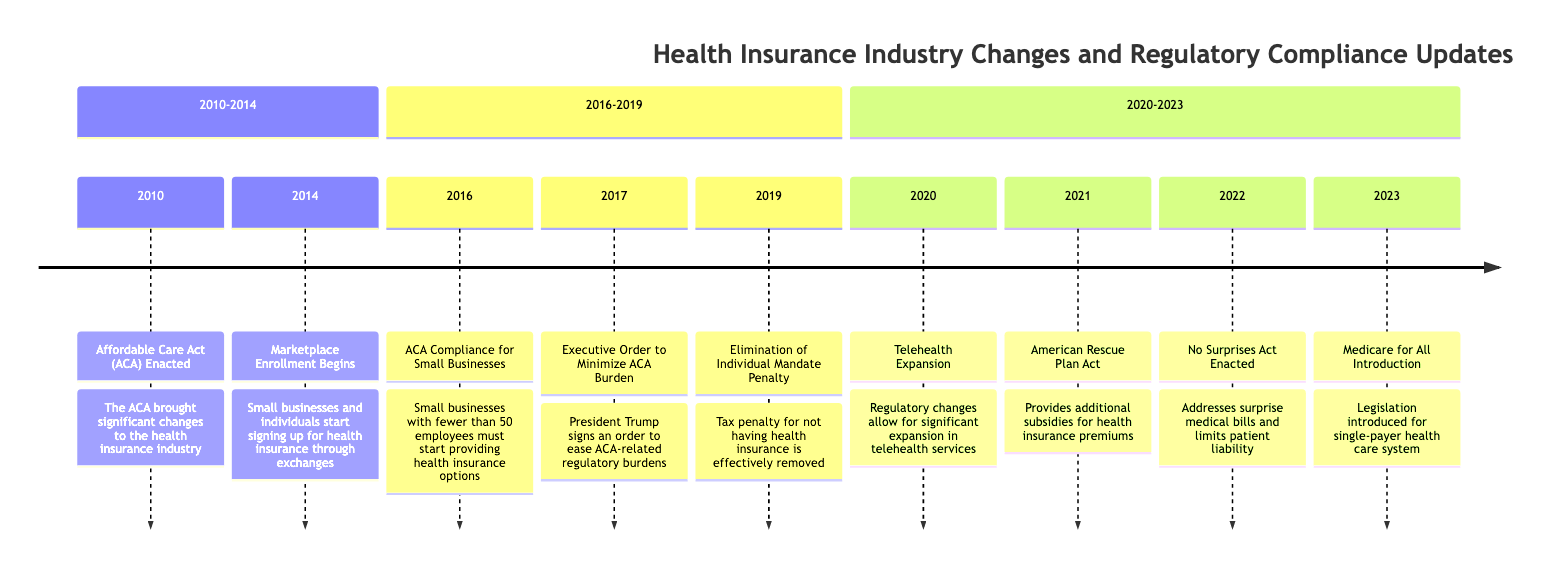What significant act was enacted in 2010? The diagram indicates that the Affordable Care Act (ACA) was enacted in 2010, making it the significant event from that year.
Answer: Affordable Care Act (ACA) In what year did Marketplace Enrollment begin? The diagram shows that Marketplace Enrollment began in 2014, as it is explicitly labeled for that year on the timeline.
Answer: 2014 What is the key requirement established for small businesses in 2016? According to the timeline, in 2016, the key requirement was that small businesses with fewer than 50 employees must start providing health insurance options.
Answer: Provide health insurance options How many events are listed between 2020 and 2023? By counting the labeled events in the section from 2020 to 2023, we find four events listed: Telehealth Expansion, American Rescue Plan Act, No Surprises Act Enacted, and Medicare for All Introduction.
Answer: 4 What act provided additional subsidies in 2021? The timeline specifies the American Rescue Plan Act as the legislation that provided additional subsidies for health insurance premiums in 2021.
Answer: American Rescue Plan Act What was the impact of the Executive Order in 2017? The diagram states that the Executive Order signed in 2017 was aimed at minimizing regulatory burdens related to the ACA, thus easing compliance requirements for businesses.
Answer: Minimize ACA burden Which law addresses surprise medical bills? The No Surprises Act, enacted in 2022, is the legislation mentioned in the timeline that specifically addresses surprise medical bills.
Answer: No Surprises Act What major healthcare proposal was introduced in 2023? The diagram indicates that in 2023, legislation for Medicare for All was introduced, aiming for a significant overhaul of the healthcare system.
Answer: Medicare for All Introduction How did the Individual Mandate Penalty change in 2019? The diagram illustrates that in 2019, the tax penalty for not having health insurance was effectively removed, changing enrollment dynamics significantly.
Answer: Removed What was a notable change in 2020 regarding healthcare services? The timeline shows that the significant change in 2020 was the expansion of telehealth services due to regulatory changes during the COVID-19 pandemic.
Answer: Telehealth Expansion 